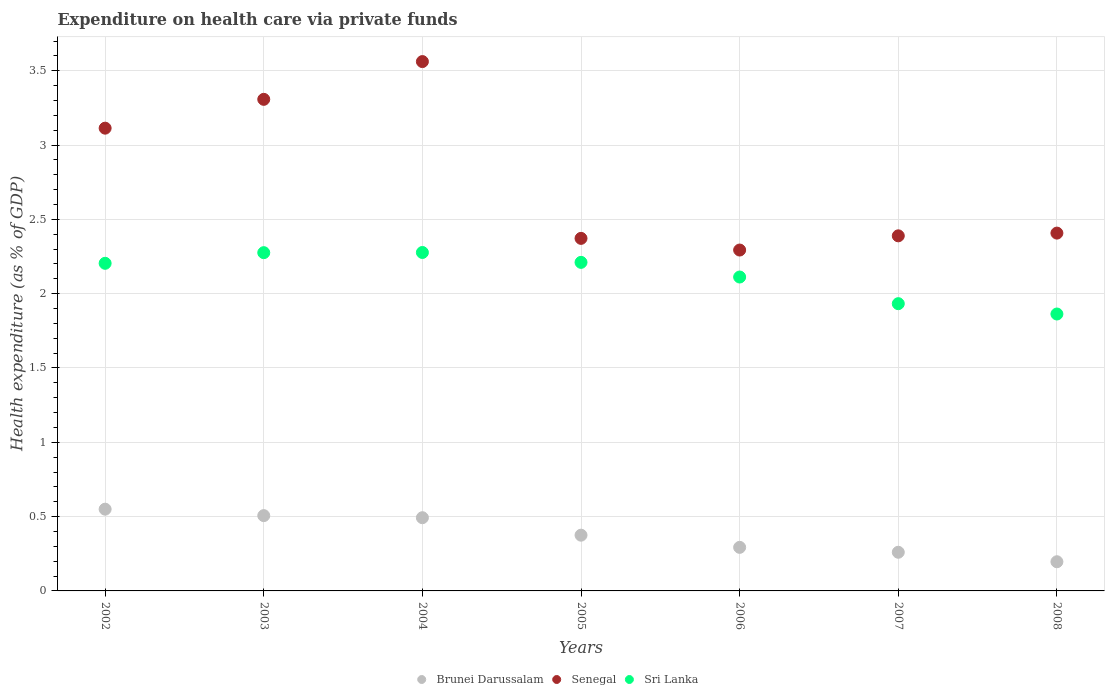Is the number of dotlines equal to the number of legend labels?
Your answer should be compact. Yes. What is the expenditure made on health care in Senegal in 2002?
Provide a succinct answer. 3.11. Across all years, what is the maximum expenditure made on health care in Senegal?
Your response must be concise. 3.56. Across all years, what is the minimum expenditure made on health care in Brunei Darussalam?
Your response must be concise. 0.2. In which year was the expenditure made on health care in Brunei Darussalam maximum?
Provide a short and direct response. 2002. What is the total expenditure made on health care in Brunei Darussalam in the graph?
Offer a terse response. 2.67. What is the difference between the expenditure made on health care in Sri Lanka in 2002 and that in 2006?
Ensure brevity in your answer.  0.09. What is the difference between the expenditure made on health care in Sri Lanka in 2002 and the expenditure made on health care in Brunei Darussalam in 2007?
Your answer should be compact. 1.94. What is the average expenditure made on health care in Brunei Darussalam per year?
Ensure brevity in your answer.  0.38. In the year 2002, what is the difference between the expenditure made on health care in Senegal and expenditure made on health care in Brunei Darussalam?
Provide a short and direct response. 2.56. In how many years, is the expenditure made on health care in Senegal greater than 0.9 %?
Ensure brevity in your answer.  7. What is the ratio of the expenditure made on health care in Brunei Darussalam in 2005 to that in 2006?
Offer a terse response. 1.28. Is the expenditure made on health care in Brunei Darussalam in 2004 less than that in 2007?
Keep it short and to the point. No. Is the difference between the expenditure made on health care in Senegal in 2003 and 2008 greater than the difference between the expenditure made on health care in Brunei Darussalam in 2003 and 2008?
Make the answer very short. Yes. What is the difference between the highest and the second highest expenditure made on health care in Senegal?
Your response must be concise. 0.25. What is the difference between the highest and the lowest expenditure made on health care in Brunei Darussalam?
Provide a short and direct response. 0.35. In how many years, is the expenditure made on health care in Senegal greater than the average expenditure made on health care in Senegal taken over all years?
Offer a very short reply. 3. Is it the case that in every year, the sum of the expenditure made on health care in Sri Lanka and expenditure made on health care in Senegal  is greater than the expenditure made on health care in Brunei Darussalam?
Ensure brevity in your answer.  Yes. Does the expenditure made on health care in Senegal monotonically increase over the years?
Ensure brevity in your answer.  No. Is the expenditure made on health care in Sri Lanka strictly less than the expenditure made on health care in Senegal over the years?
Your response must be concise. Yes. How many years are there in the graph?
Ensure brevity in your answer.  7. Does the graph contain any zero values?
Provide a succinct answer. No. Does the graph contain grids?
Make the answer very short. Yes. How many legend labels are there?
Provide a succinct answer. 3. What is the title of the graph?
Make the answer very short. Expenditure on health care via private funds. What is the label or title of the Y-axis?
Your answer should be very brief. Health expenditure (as % of GDP). What is the Health expenditure (as % of GDP) of Brunei Darussalam in 2002?
Your answer should be very brief. 0.55. What is the Health expenditure (as % of GDP) of Senegal in 2002?
Provide a short and direct response. 3.11. What is the Health expenditure (as % of GDP) in Sri Lanka in 2002?
Offer a very short reply. 2.2. What is the Health expenditure (as % of GDP) in Brunei Darussalam in 2003?
Ensure brevity in your answer.  0.51. What is the Health expenditure (as % of GDP) of Senegal in 2003?
Provide a short and direct response. 3.31. What is the Health expenditure (as % of GDP) of Sri Lanka in 2003?
Make the answer very short. 2.28. What is the Health expenditure (as % of GDP) in Brunei Darussalam in 2004?
Provide a succinct answer. 0.49. What is the Health expenditure (as % of GDP) in Senegal in 2004?
Offer a terse response. 3.56. What is the Health expenditure (as % of GDP) in Sri Lanka in 2004?
Provide a succinct answer. 2.28. What is the Health expenditure (as % of GDP) in Brunei Darussalam in 2005?
Keep it short and to the point. 0.38. What is the Health expenditure (as % of GDP) in Senegal in 2005?
Your response must be concise. 2.37. What is the Health expenditure (as % of GDP) of Sri Lanka in 2005?
Offer a terse response. 2.21. What is the Health expenditure (as % of GDP) of Brunei Darussalam in 2006?
Your answer should be compact. 0.29. What is the Health expenditure (as % of GDP) of Senegal in 2006?
Offer a very short reply. 2.29. What is the Health expenditure (as % of GDP) in Sri Lanka in 2006?
Give a very brief answer. 2.11. What is the Health expenditure (as % of GDP) in Brunei Darussalam in 2007?
Make the answer very short. 0.26. What is the Health expenditure (as % of GDP) in Senegal in 2007?
Your answer should be very brief. 2.39. What is the Health expenditure (as % of GDP) in Sri Lanka in 2007?
Your answer should be compact. 1.93. What is the Health expenditure (as % of GDP) in Brunei Darussalam in 2008?
Ensure brevity in your answer.  0.2. What is the Health expenditure (as % of GDP) in Senegal in 2008?
Offer a very short reply. 2.41. What is the Health expenditure (as % of GDP) in Sri Lanka in 2008?
Provide a succinct answer. 1.86. Across all years, what is the maximum Health expenditure (as % of GDP) in Brunei Darussalam?
Your answer should be very brief. 0.55. Across all years, what is the maximum Health expenditure (as % of GDP) in Senegal?
Offer a very short reply. 3.56. Across all years, what is the maximum Health expenditure (as % of GDP) of Sri Lanka?
Make the answer very short. 2.28. Across all years, what is the minimum Health expenditure (as % of GDP) of Brunei Darussalam?
Keep it short and to the point. 0.2. Across all years, what is the minimum Health expenditure (as % of GDP) in Senegal?
Provide a succinct answer. 2.29. Across all years, what is the minimum Health expenditure (as % of GDP) of Sri Lanka?
Your answer should be compact. 1.86. What is the total Health expenditure (as % of GDP) in Brunei Darussalam in the graph?
Offer a terse response. 2.67. What is the total Health expenditure (as % of GDP) in Senegal in the graph?
Make the answer very short. 19.45. What is the total Health expenditure (as % of GDP) of Sri Lanka in the graph?
Offer a very short reply. 14.88. What is the difference between the Health expenditure (as % of GDP) in Brunei Darussalam in 2002 and that in 2003?
Your answer should be very brief. 0.04. What is the difference between the Health expenditure (as % of GDP) of Senegal in 2002 and that in 2003?
Make the answer very short. -0.19. What is the difference between the Health expenditure (as % of GDP) of Sri Lanka in 2002 and that in 2003?
Your response must be concise. -0.07. What is the difference between the Health expenditure (as % of GDP) in Brunei Darussalam in 2002 and that in 2004?
Make the answer very short. 0.06. What is the difference between the Health expenditure (as % of GDP) in Senegal in 2002 and that in 2004?
Provide a succinct answer. -0.45. What is the difference between the Health expenditure (as % of GDP) in Sri Lanka in 2002 and that in 2004?
Ensure brevity in your answer.  -0.07. What is the difference between the Health expenditure (as % of GDP) in Brunei Darussalam in 2002 and that in 2005?
Give a very brief answer. 0.17. What is the difference between the Health expenditure (as % of GDP) in Senegal in 2002 and that in 2005?
Your answer should be compact. 0.74. What is the difference between the Health expenditure (as % of GDP) in Sri Lanka in 2002 and that in 2005?
Provide a short and direct response. -0.01. What is the difference between the Health expenditure (as % of GDP) of Brunei Darussalam in 2002 and that in 2006?
Provide a short and direct response. 0.26. What is the difference between the Health expenditure (as % of GDP) of Senegal in 2002 and that in 2006?
Provide a succinct answer. 0.82. What is the difference between the Health expenditure (as % of GDP) in Sri Lanka in 2002 and that in 2006?
Your answer should be compact. 0.09. What is the difference between the Health expenditure (as % of GDP) in Brunei Darussalam in 2002 and that in 2007?
Offer a terse response. 0.29. What is the difference between the Health expenditure (as % of GDP) of Senegal in 2002 and that in 2007?
Offer a terse response. 0.72. What is the difference between the Health expenditure (as % of GDP) in Sri Lanka in 2002 and that in 2007?
Provide a short and direct response. 0.27. What is the difference between the Health expenditure (as % of GDP) of Brunei Darussalam in 2002 and that in 2008?
Give a very brief answer. 0.35. What is the difference between the Health expenditure (as % of GDP) of Senegal in 2002 and that in 2008?
Give a very brief answer. 0.71. What is the difference between the Health expenditure (as % of GDP) in Sri Lanka in 2002 and that in 2008?
Provide a short and direct response. 0.34. What is the difference between the Health expenditure (as % of GDP) of Brunei Darussalam in 2003 and that in 2004?
Offer a terse response. 0.01. What is the difference between the Health expenditure (as % of GDP) in Senegal in 2003 and that in 2004?
Keep it short and to the point. -0.25. What is the difference between the Health expenditure (as % of GDP) in Sri Lanka in 2003 and that in 2004?
Provide a succinct answer. -0. What is the difference between the Health expenditure (as % of GDP) in Brunei Darussalam in 2003 and that in 2005?
Offer a very short reply. 0.13. What is the difference between the Health expenditure (as % of GDP) of Senegal in 2003 and that in 2005?
Offer a very short reply. 0.94. What is the difference between the Health expenditure (as % of GDP) in Sri Lanka in 2003 and that in 2005?
Offer a very short reply. 0.07. What is the difference between the Health expenditure (as % of GDP) in Brunei Darussalam in 2003 and that in 2006?
Provide a short and direct response. 0.21. What is the difference between the Health expenditure (as % of GDP) of Sri Lanka in 2003 and that in 2006?
Keep it short and to the point. 0.16. What is the difference between the Health expenditure (as % of GDP) of Brunei Darussalam in 2003 and that in 2007?
Your answer should be compact. 0.25. What is the difference between the Health expenditure (as % of GDP) of Senegal in 2003 and that in 2007?
Offer a terse response. 0.92. What is the difference between the Health expenditure (as % of GDP) of Sri Lanka in 2003 and that in 2007?
Your answer should be very brief. 0.34. What is the difference between the Health expenditure (as % of GDP) in Brunei Darussalam in 2003 and that in 2008?
Ensure brevity in your answer.  0.31. What is the difference between the Health expenditure (as % of GDP) in Senegal in 2003 and that in 2008?
Your response must be concise. 0.9. What is the difference between the Health expenditure (as % of GDP) in Sri Lanka in 2003 and that in 2008?
Your response must be concise. 0.41. What is the difference between the Health expenditure (as % of GDP) of Brunei Darussalam in 2004 and that in 2005?
Your answer should be compact. 0.12. What is the difference between the Health expenditure (as % of GDP) of Senegal in 2004 and that in 2005?
Your response must be concise. 1.19. What is the difference between the Health expenditure (as % of GDP) in Sri Lanka in 2004 and that in 2005?
Give a very brief answer. 0.07. What is the difference between the Health expenditure (as % of GDP) in Brunei Darussalam in 2004 and that in 2006?
Offer a very short reply. 0.2. What is the difference between the Health expenditure (as % of GDP) of Senegal in 2004 and that in 2006?
Your answer should be very brief. 1.27. What is the difference between the Health expenditure (as % of GDP) in Sri Lanka in 2004 and that in 2006?
Keep it short and to the point. 0.17. What is the difference between the Health expenditure (as % of GDP) in Brunei Darussalam in 2004 and that in 2007?
Make the answer very short. 0.23. What is the difference between the Health expenditure (as % of GDP) in Senegal in 2004 and that in 2007?
Provide a short and direct response. 1.17. What is the difference between the Health expenditure (as % of GDP) in Sri Lanka in 2004 and that in 2007?
Your answer should be compact. 0.34. What is the difference between the Health expenditure (as % of GDP) of Brunei Darussalam in 2004 and that in 2008?
Ensure brevity in your answer.  0.3. What is the difference between the Health expenditure (as % of GDP) in Senegal in 2004 and that in 2008?
Provide a short and direct response. 1.15. What is the difference between the Health expenditure (as % of GDP) of Sri Lanka in 2004 and that in 2008?
Offer a very short reply. 0.41. What is the difference between the Health expenditure (as % of GDP) in Brunei Darussalam in 2005 and that in 2006?
Provide a succinct answer. 0.08. What is the difference between the Health expenditure (as % of GDP) in Senegal in 2005 and that in 2006?
Your answer should be compact. 0.08. What is the difference between the Health expenditure (as % of GDP) in Sri Lanka in 2005 and that in 2006?
Give a very brief answer. 0.1. What is the difference between the Health expenditure (as % of GDP) of Brunei Darussalam in 2005 and that in 2007?
Ensure brevity in your answer.  0.12. What is the difference between the Health expenditure (as % of GDP) in Senegal in 2005 and that in 2007?
Provide a succinct answer. -0.02. What is the difference between the Health expenditure (as % of GDP) in Sri Lanka in 2005 and that in 2007?
Offer a very short reply. 0.28. What is the difference between the Health expenditure (as % of GDP) in Brunei Darussalam in 2005 and that in 2008?
Give a very brief answer. 0.18. What is the difference between the Health expenditure (as % of GDP) of Senegal in 2005 and that in 2008?
Give a very brief answer. -0.04. What is the difference between the Health expenditure (as % of GDP) of Sri Lanka in 2005 and that in 2008?
Your answer should be very brief. 0.35. What is the difference between the Health expenditure (as % of GDP) in Brunei Darussalam in 2006 and that in 2007?
Keep it short and to the point. 0.03. What is the difference between the Health expenditure (as % of GDP) in Senegal in 2006 and that in 2007?
Offer a terse response. -0.1. What is the difference between the Health expenditure (as % of GDP) in Sri Lanka in 2006 and that in 2007?
Your response must be concise. 0.18. What is the difference between the Health expenditure (as % of GDP) in Brunei Darussalam in 2006 and that in 2008?
Provide a succinct answer. 0.1. What is the difference between the Health expenditure (as % of GDP) in Senegal in 2006 and that in 2008?
Provide a short and direct response. -0.11. What is the difference between the Health expenditure (as % of GDP) in Sri Lanka in 2006 and that in 2008?
Keep it short and to the point. 0.25. What is the difference between the Health expenditure (as % of GDP) of Brunei Darussalam in 2007 and that in 2008?
Keep it short and to the point. 0.06. What is the difference between the Health expenditure (as % of GDP) in Senegal in 2007 and that in 2008?
Keep it short and to the point. -0.02. What is the difference between the Health expenditure (as % of GDP) of Sri Lanka in 2007 and that in 2008?
Provide a short and direct response. 0.07. What is the difference between the Health expenditure (as % of GDP) in Brunei Darussalam in 2002 and the Health expenditure (as % of GDP) in Senegal in 2003?
Offer a very short reply. -2.76. What is the difference between the Health expenditure (as % of GDP) in Brunei Darussalam in 2002 and the Health expenditure (as % of GDP) in Sri Lanka in 2003?
Ensure brevity in your answer.  -1.73. What is the difference between the Health expenditure (as % of GDP) of Senegal in 2002 and the Health expenditure (as % of GDP) of Sri Lanka in 2003?
Make the answer very short. 0.84. What is the difference between the Health expenditure (as % of GDP) in Brunei Darussalam in 2002 and the Health expenditure (as % of GDP) in Senegal in 2004?
Keep it short and to the point. -3.01. What is the difference between the Health expenditure (as % of GDP) of Brunei Darussalam in 2002 and the Health expenditure (as % of GDP) of Sri Lanka in 2004?
Provide a succinct answer. -1.73. What is the difference between the Health expenditure (as % of GDP) of Senegal in 2002 and the Health expenditure (as % of GDP) of Sri Lanka in 2004?
Your answer should be very brief. 0.84. What is the difference between the Health expenditure (as % of GDP) in Brunei Darussalam in 2002 and the Health expenditure (as % of GDP) in Senegal in 2005?
Your response must be concise. -1.82. What is the difference between the Health expenditure (as % of GDP) of Brunei Darussalam in 2002 and the Health expenditure (as % of GDP) of Sri Lanka in 2005?
Your answer should be compact. -1.66. What is the difference between the Health expenditure (as % of GDP) in Senegal in 2002 and the Health expenditure (as % of GDP) in Sri Lanka in 2005?
Make the answer very short. 0.9. What is the difference between the Health expenditure (as % of GDP) of Brunei Darussalam in 2002 and the Health expenditure (as % of GDP) of Senegal in 2006?
Your answer should be compact. -1.74. What is the difference between the Health expenditure (as % of GDP) of Brunei Darussalam in 2002 and the Health expenditure (as % of GDP) of Sri Lanka in 2006?
Give a very brief answer. -1.56. What is the difference between the Health expenditure (as % of GDP) in Brunei Darussalam in 2002 and the Health expenditure (as % of GDP) in Senegal in 2007?
Give a very brief answer. -1.84. What is the difference between the Health expenditure (as % of GDP) in Brunei Darussalam in 2002 and the Health expenditure (as % of GDP) in Sri Lanka in 2007?
Provide a short and direct response. -1.38. What is the difference between the Health expenditure (as % of GDP) of Senegal in 2002 and the Health expenditure (as % of GDP) of Sri Lanka in 2007?
Make the answer very short. 1.18. What is the difference between the Health expenditure (as % of GDP) in Brunei Darussalam in 2002 and the Health expenditure (as % of GDP) in Senegal in 2008?
Offer a terse response. -1.86. What is the difference between the Health expenditure (as % of GDP) of Brunei Darussalam in 2002 and the Health expenditure (as % of GDP) of Sri Lanka in 2008?
Your answer should be compact. -1.31. What is the difference between the Health expenditure (as % of GDP) in Senegal in 2002 and the Health expenditure (as % of GDP) in Sri Lanka in 2008?
Offer a very short reply. 1.25. What is the difference between the Health expenditure (as % of GDP) in Brunei Darussalam in 2003 and the Health expenditure (as % of GDP) in Senegal in 2004?
Your answer should be very brief. -3.06. What is the difference between the Health expenditure (as % of GDP) in Brunei Darussalam in 2003 and the Health expenditure (as % of GDP) in Sri Lanka in 2004?
Offer a very short reply. -1.77. What is the difference between the Health expenditure (as % of GDP) of Senegal in 2003 and the Health expenditure (as % of GDP) of Sri Lanka in 2004?
Give a very brief answer. 1.03. What is the difference between the Health expenditure (as % of GDP) of Brunei Darussalam in 2003 and the Health expenditure (as % of GDP) of Senegal in 2005?
Offer a very short reply. -1.87. What is the difference between the Health expenditure (as % of GDP) in Brunei Darussalam in 2003 and the Health expenditure (as % of GDP) in Sri Lanka in 2005?
Offer a terse response. -1.7. What is the difference between the Health expenditure (as % of GDP) in Senegal in 2003 and the Health expenditure (as % of GDP) in Sri Lanka in 2005?
Keep it short and to the point. 1.1. What is the difference between the Health expenditure (as % of GDP) in Brunei Darussalam in 2003 and the Health expenditure (as % of GDP) in Senegal in 2006?
Make the answer very short. -1.79. What is the difference between the Health expenditure (as % of GDP) of Brunei Darussalam in 2003 and the Health expenditure (as % of GDP) of Sri Lanka in 2006?
Keep it short and to the point. -1.61. What is the difference between the Health expenditure (as % of GDP) of Senegal in 2003 and the Health expenditure (as % of GDP) of Sri Lanka in 2006?
Offer a terse response. 1.2. What is the difference between the Health expenditure (as % of GDP) of Brunei Darussalam in 2003 and the Health expenditure (as % of GDP) of Senegal in 2007?
Ensure brevity in your answer.  -1.88. What is the difference between the Health expenditure (as % of GDP) of Brunei Darussalam in 2003 and the Health expenditure (as % of GDP) of Sri Lanka in 2007?
Offer a terse response. -1.43. What is the difference between the Health expenditure (as % of GDP) in Senegal in 2003 and the Health expenditure (as % of GDP) in Sri Lanka in 2007?
Ensure brevity in your answer.  1.37. What is the difference between the Health expenditure (as % of GDP) in Brunei Darussalam in 2003 and the Health expenditure (as % of GDP) in Senegal in 2008?
Provide a succinct answer. -1.9. What is the difference between the Health expenditure (as % of GDP) of Brunei Darussalam in 2003 and the Health expenditure (as % of GDP) of Sri Lanka in 2008?
Provide a short and direct response. -1.36. What is the difference between the Health expenditure (as % of GDP) of Senegal in 2003 and the Health expenditure (as % of GDP) of Sri Lanka in 2008?
Your answer should be compact. 1.44. What is the difference between the Health expenditure (as % of GDP) in Brunei Darussalam in 2004 and the Health expenditure (as % of GDP) in Senegal in 2005?
Provide a short and direct response. -1.88. What is the difference between the Health expenditure (as % of GDP) in Brunei Darussalam in 2004 and the Health expenditure (as % of GDP) in Sri Lanka in 2005?
Keep it short and to the point. -1.72. What is the difference between the Health expenditure (as % of GDP) of Senegal in 2004 and the Health expenditure (as % of GDP) of Sri Lanka in 2005?
Give a very brief answer. 1.35. What is the difference between the Health expenditure (as % of GDP) in Brunei Darussalam in 2004 and the Health expenditure (as % of GDP) in Senegal in 2006?
Give a very brief answer. -1.8. What is the difference between the Health expenditure (as % of GDP) in Brunei Darussalam in 2004 and the Health expenditure (as % of GDP) in Sri Lanka in 2006?
Provide a succinct answer. -1.62. What is the difference between the Health expenditure (as % of GDP) in Senegal in 2004 and the Health expenditure (as % of GDP) in Sri Lanka in 2006?
Give a very brief answer. 1.45. What is the difference between the Health expenditure (as % of GDP) in Brunei Darussalam in 2004 and the Health expenditure (as % of GDP) in Senegal in 2007?
Provide a succinct answer. -1.9. What is the difference between the Health expenditure (as % of GDP) in Brunei Darussalam in 2004 and the Health expenditure (as % of GDP) in Sri Lanka in 2007?
Your response must be concise. -1.44. What is the difference between the Health expenditure (as % of GDP) in Senegal in 2004 and the Health expenditure (as % of GDP) in Sri Lanka in 2007?
Provide a succinct answer. 1.63. What is the difference between the Health expenditure (as % of GDP) in Brunei Darussalam in 2004 and the Health expenditure (as % of GDP) in Senegal in 2008?
Ensure brevity in your answer.  -1.92. What is the difference between the Health expenditure (as % of GDP) in Brunei Darussalam in 2004 and the Health expenditure (as % of GDP) in Sri Lanka in 2008?
Offer a very short reply. -1.37. What is the difference between the Health expenditure (as % of GDP) of Senegal in 2004 and the Health expenditure (as % of GDP) of Sri Lanka in 2008?
Your response must be concise. 1.7. What is the difference between the Health expenditure (as % of GDP) in Brunei Darussalam in 2005 and the Health expenditure (as % of GDP) in Senegal in 2006?
Make the answer very short. -1.92. What is the difference between the Health expenditure (as % of GDP) in Brunei Darussalam in 2005 and the Health expenditure (as % of GDP) in Sri Lanka in 2006?
Ensure brevity in your answer.  -1.74. What is the difference between the Health expenditure (as % of GDP) in Senegal in 2005 and the Health expenditure (as % of GDP) in Sri Lanka in 2006?
Ensure brevity in your answer.  0.26. What is the difference between the Health expenditure (as % of GDP) in Brunei Darussalam in 2005 and the Health expenditure (as % of GDP) in Senegal in 2007?
Offer a terse response. -2.01. What is the difference between the Health expenditure (as % of GDP) in Brunei Darussalam in 2005 and the Health expenditure (as % of GDP) in Sri Lanka in 2007?
Offer a very short reply. -1.56. What is the difference between the Health expenditure (as % of GDP) of Senegal in 2005 and the Health expenditure (as % of GDP) of Sri Lanka in 2007?
Offer a terse response. 0.44. What is the difference between the Health expenditure (as % of GDP) of Brunei Darussalam in 2005 and the Health expenditure (as % of GDP) of Senegal in 2008?
Keep it short and to the point. -2.03. What is the difference between the Health expenditure (as % of GDP) of Brunei Darussalam in 2005 and the Health expenditure (as % of GDP) of Sri Lanka in 2008?
Your answer should be compact. -1.49. What is the difference between the Health expenditure (as % of GDP) of Senegal in 2005 and the Health expenditure (as % of GDP) of Sri Lanka in 2008?
Offer a terse response. 0.51. What is the difference between the Health expenditure (as % of GDP) in Brunei Darussalam in 2006 and the Health expenditure (as % of GDP) in Senegal in 2007?
Your answer should be compact. -2.1. What is the difference between the Health expenditure (as % of GDP) in Brunei Darussalam in 2006 and the Health expenditure (as % of GDP) in Sri Lanka in 2007?
Provide a succinct answer. -1.64. What is the difference between the Health expenditure (as % of GDP) of Senegal in 2006 and the Health expenditure (as % of GDP) of Sri Lanka in 2007?
Your answer should be compact. 0.36. What is the difference between the Health expenditure (as % of GDP) of Brunei Darussalam in 2006 and the Health expenditure (as % of GDP) of Senegal in 2008?
Offer a very short reply. -2.11. What is the difference between the Health expenditure (as % of GDP) of Brunei Darussalam in 2006 and the Health expenditure (as % of GDP) of Sri Lanka in 2008?
Provide a short and direct response. -1.57. What is the difference between the Health expenditure (as % of GDP) of Senegal in 2006 and the Health expenditure (as % of GDP) of Sri Lanka in 2008?
Your answer should be very brief. 0.43. What is the difference between the Health expenditure (as % of GDP) of Brunei Darussalam in 2007 and the Health expenditure (as % of GDP) of Senegal in 2008?
Make the answer very short. -2.15. What is the difference between the Health expenditure (as % of GDP) in Brunei Darussalam in 2007 and the Health expenditure (as % of GDP) in Sri Lanka in 2008?
Provide a succinct answer. -1.6. What is the difference between the Health expenditure (as % of GDP) in Senegal in 2007 and the Health expenditure (as % of GDP) in Sri Lanka in 2008?
Your response must be concise. 0.53. What is the average Health expenditure (as % of GDP) of Brunei Darussalam per year?
Provide a short and direct response. 0.38. What is the average Health expenditure (as % of GDP) of Senegal per year?
Ensure brevity in your answer.  2.78. What is the average Health expenditure (as % of GDP) of Sri Lanka per year?
Make the answer very short. 2.13. In the year 2002, what is the difference between the Health expenditure (as % of GDP) in Brunei Darussalam and Health expenditure (as % of GDP) in Senegal?
Provide a succinct answer. -2.56. In the year 2002, what is the difference between the Health expenditure (as % of GDP) in Brunei Darussalam and Health expenditure (as % of GDP) in Sri Lanka?
Your answer should be very brief. -1.65. In the year 2002, what is the difference between the Health expenditure (as % of GDP) of Senegal and Health expenditure (as % of GDP) of Sri Lanka?
Offer a terse response. 0.91. In the year 2003, what is the difference between the Health expenditure (as % of GDP) of Brunei Darussalam and Health expenditure (as % of GDP) of Senegal?
Offer a very short reply. -2.8. In the year 2003, what is the difference between the Health expenditure (as % of GDP) in Brunei Darussalam and Health expenditure (as % of GDP) in Sri Lanka?
Your answer should be compact. -1.77. In the year 2003, what is the difference between the Health expenditure (as % of GDP) of Senegal and Health expenditure (as % of GDP) of Sri Lanka?
Your response must be concise. 1.03. In the year 2004, what is the difference between the Health expenditure (as % of GDP) of Brunei Darussalam and Health expenditure (as % of GDP) of Senegal?
Offer a terse response. -3.07. In the year 2004, what is the difference between the Health expenditure (as % of GDP) of Brunei Darussalam and Health expenditure (as % of GDP) of Sri Lanka?
Your answer should be compact. -1.78. In the year 2004, what is the difference between the Health expenditure (as % of GDP) in Senegal and Health expenditure (as % of GDP) in Sri Lanka?
Your response must be concise. 1.28. In the year 2005, what is the difference between the Health expenditure (as % of GDP) of Brunei Darussalam and Health expenditure (as % of GDP) of Senegal?
Make the answer very short. -2. In the year 2005, what is the difference between the Health expenditure (as % of GDP) of Brunei Darussalam and Health expenditure (as % of GDP) of Sri Lanka?
Your response must be concise. -1.84. In the year 2005, what is the difference between the Health expenditure (as % of GDP) of Senegal and Health expenditure (as % of GDP) of Sri Lanka?
Your answer should be compact. 0.16. In the year 2006, what is the difference between the Health expenditure (as % of GDP) in Brunei Darussalam and Health expenditure (as % of GDP) in Senegal?
Your response must be concise. -2. In the year 2006, what is the difference between the Health expenditure (as % of GDP) in Brunei Darussalam and Health expenditure (as % of GDP) in Sri Lanka?
Offer a very short reply. -1.82. In the year 2006, what is the difference between the Health expenditure (as % of GDP) of Senegal and Health expenditure (as % of GDP) of Sri Lanka?
Provide a succinct answer. 0.18. In the year 2007, what is the difference between the Health expenditure (as % of GDP) of Brunei Darussalam and Health expenditure (as % of GDP) of Senegal?
Offer a very short reply. -2.13. In the year 2007, what is the difference between the Health expenditure (as % of GDP) of Brunei Darussalam and Health expenditure (as % of GDP) of Sri Lanka?
Ensure brevity in your answer.  -1.67. In the year 2007, what is the difference between the Health expenditure (as % of GDP) of Senegal and Health expenditure (as % of GDP) of Sri Lanka?
Offer a very short reply. 0.46. In the year 2008, what is the difference between the Health expenditure (as % of GDP) in Brunei Darussalam and Health expenditure (as % of GDP) in Senegal?
Provide a succinct answer. -2.21. In the year 2008, what is the difference between the Health expenditure (as % of GDP) in Brunei Darussalam and Health expenditure (as % of GDP) in Sri Lanka?
Your answer should be very brief. -1.67. In the year 2008, what is the difference between the Health expenditure (as % of GDP) in Senegal and Health expenditure (as % of GDP) in Sri Lanka?
Ensure brevity in your answer.  0.54. What is the ratio of the Health expenditure (as % of GDP) in Brunei Darussalam in 2002 to that in 2003?
Offer a terse response. 1.09. What is the ratio of the Health expenditure (as % of GDP) of Senegal in 2002 to that in 2003?
Your answer should be very brief. 0.94. What is the ratio of the Health expenditure (as % of GDP) in Sri Lanka in 2002 to that in 2003?
Give a very brief answer. 0.97. What is the ratio of the Health expenditure (as % of GDP) in Brunei Darussalam in 2002 to that in 2004?
Give a very brief answer. 1.12. What is the ratio of the Health expenditure (as % of GDP) in Senegal in 2002 to that in 2004?
Your response must be concise. 0.87. What is the ratio of the Health expenditure (as % of GDP) of Brunei Darussalam in 2002 to that in 2005?
Your response must be concise. 1.47. What is the ratio of the Health expenditure (as % of GDP) in Senegal in 2002 to that in 2005?
Make the answer very short. 1.31. What is the ratio of the Health expenditure (as % of GDP) in Brunei Darussalam in 2002 to that in 2006?
Offer a very short reply. 1.88. What is the ratio of the Health expenditure (as % of GDP) in Senegal in 2002 to that in 2006?
Offer a very short reply. 1.36. What is the ratio of the Health expenditure (as % of GDP) in Sri Lanka in 2002 to that in 2006?
Offer a very short reply. 1.04. What is the ratio of the Health expenditure (as % of GDP) of Brunei Darussalam in 2002 to that in 2007?
Your answer should be compact. 2.11. What is the ratio of the Health expenditure (as % of GDP) in Senegal in 2002 to that in 2007?
Offer a very short reply. 1.3. What is the ratio of the Health expenditure (as % of GDP) in Sri Lanka in 2002 to that in 2007?
Ensure brevity in your answer.  1.14. What is the ratio of the Health expenditure (as % of GDP) in Brunei Darussalam in 2002 to that in 2008?
Ensure brevity in your answer.  2.8. What is the ratio of the Health expenditure (as % of GDP) in Senegal in 2002 to that in 2008?
Offer a very short reply. 1.29. What is the ratio of the Health expenditure (as % of GDP) of Sri Lanka in 2002 to that in 2008?
Provide a succinct answer. 1.18. What is the ratio of the Health expenditure (as % of GDP) in Brunei Darussalam in 2003 to that in 2004?
Your response must be concise. 1.03. What is the ratio of the Health expenditure (as % of GDP) of Senegal in 2003 to that in 2004?
Offer a very short reply. 0.93. What is the ratio of the Health expenditure (as % of GDP) in Sri Lanka in 2003 to that in 2004?
Your response must be concise. 1. What is the ratio of the Health expenditure (as % of GDP) in Brunei Darussalam in 2003 to that in 2005?
Your answer should be compact. 1.35. What is the ratio of the Health expenditure (as % of GDP) in Senegal in 2003 to that in 2005?
Keep it short and to the point. 1.39. What is the ratio of the Health expenditure (as % of GDP) in Sri Lanka in 2003 to that in 2005?
Offer a very short reply. 1.03. What is the ratio of the Health expenditure (as % of GDP) of Brunei Darussalam in 2003 to that in 2006?
Offer a very short reply. 1.73. What is the ratio of the Health expenditure (as % of GDP) of Senegal in 2003 to that in 2006?
Your answer should be compact. 1.44. What is the ratio of the Health expenditure (as % of GDP) of Sri Lanka in 2003 to that in 2006?
Provide a short and direct response. 1.08. What is the ratio of the Health expenditure (as % of GDP) of Brunei Darussalam in 2003 to that in 2007?
Provide a succinct answer. 1.95. What is the ratio of the Health expenditure (as % of GDP) of Senegal in 2003 to that in 2007?
Keep it short and to the point. 1.38. What is the ratio of the Health expenditure (as % of GDP) of Sri Lanka in 2003 to that in 2007?
Your answer should be compact. 1.18. What is the ratio of the Health expenditure (as % of GDP) of Brunei Darussalam in 2003 to that in 2008?
Offer a very short reply. 2.58. What is the ratio of the Health expenditure (as % of GDP) in Senegal in 2003 to that in 2008?
Keep it short and to the point. 1.37. What is the ratio of the Health expenditure (as % of GDP) of Sri Lanka in 2003 to that in 2008?
Make the answer very short. 1.22. What is the ratio of the Health expenditure (as % of GDP) of Brunei Darussalam in 2004 to that in 2005?
Provide a short and direct response. 1.31. What is the ratio of the Health expenditure (as % of GDP) of Senegal in 2004 to that in 2005?
Your response must be concise. 1.5. What is the ratio of the Health expenditure (as % of GDP) of Sri Lanka in 2004 to that in 2005?
Offer a very short reply. 1.03. What is the ratio of the Health expenditure (as % of GDP) in Brunei Darussalam in 2004 to that in 2006?
Make the answer very short. 1.68. What is the ratio of the Health expenditure (as % of GDP) of Senegal in 2004 to that in 2006?
Offer a terse response. 1.55. What is the ratio of the Health expenditure (as % of GDP) in Sri Lanka in 2004 to that in 2006?
Keep it short and to the point. 1.08. What is the ratio of the Health expenditure (as % of GDP) in Brunei Darussalam in 2004 to that in 2007?
Offer a terse response. 1.89. What is the ratio of the Health expenditure (as % of GDP) in Senegal in 2004 to that in 2007?
Your answer should be very brief. 1.49. What is the ratio of the Health expenditure (as % of GDP) of Sri Lanka in 2004 to that in 2007?
Offer a very short reply. 1.18. What is the ratio of the Health expenditure (as % of GDP) in Brunei Darussalam in 2004 to that in 2008?
Your answer should be compact. 2.51. What is the ratio of the Health expenditure (as % of GDP) of Senegal in 2004 to that in 2008?
Make the answer very short. 1.48. What is the ratio of the Health expenditure (as % of GDP) in Sri Lanka in 2004 to that in 2008?
Your response must be concise. 1.22. What is the ratio of the Health expenditure (as % of GDP) in Brunei Darussalam in 2005 to that in 2006?
Make the answer very short. 1.28. What is the ratio of the Health expenditure (as % of GDP) of Senegal in 2005 to that in 2006?
Your answer should be very brief. 1.03. What is the ratio of the Health expenditure (as % of GDP) in Sri Lanka in 2005 to that in 2006?
Your answer should be compact. 1.05. What is the ratio of the Health expenditure (as % of GDP) in Brunei Darussalam in 2005 to that in 2007?
Your answer should be compact. 1.44. What is the ratio of the Health expenditure (as % of GDP) in Sri Lanka in 2005 to that in 2007?
Offer a very short reply. 1.14. What is the ratio of the Health expenditure (as % of GDP) in Brunei Darussalam in 2005 to that in 2008?
Offer a very short reply. 1.91. What is the ratio of the Health expenditure (as % of GDP) in Sri Lanka in 2005 to that in 2008?
Give a very brief answer. 1.19. What is the ratio of the Health expenditure (as % of GDP) of Brunei Darussalam in 2006 to that in 2007?
Provide a succinct answer. 1.13. What is the ratio of the Health expenditure (as % of GDP) in Senegal in 2006 to that in 2007?
Offer a terse response. 0.96. What is the ratio of the Health expenditure (as % of GDP) in Sri Lanka in 2006 to that in 2007?
Your answer should be compact. 1.09. What is the ratio of the Health expenditure (as % of GDP) in Brunei Darussalam in 2006 to that in 2008?
Your answer should be compact. 1.49. What is the ratio of the Health expenditure (as % of GDP) in Senegal in 2006 to that in 2008?
Provide a short and direct response. 0.95. What is the ratio of the Health expenditure (as % of GDP) in Sri Lanka in 2006 to that in 2008?
Offer a terse response. 1.13. What is the ratio of the Health expenditure (as % of GDP) of Brunei Darussalam in 2007 to that in 2008?
Offer a terse response. 1.32. What is the ratio of the Health expenditure (as % of GDP) in Senegal in 2007 to that in 2008?
Your answer should be very brief. 0.99. What is the ratio of the Health expenditure (as % of GDP) in Sri Lanka in 2007 to that in 2008?
Provide a short and direct response. 1.04. What is the difference between the highest and the second highest Health expenditure (as % of GDP) in Brunei Darussalam?
Your answer should be compact. 0.04. What is the difference between the highest and the second highest Health expenditure (as % of GDP) in Senegal?
Your response must be concise. 0.25. What is the difference between the highest and the second highest Health expenditure (as % of GDP) in Sri Lanka?
Your response must be concise. 0. What is the difference between the highest and the lowest Health expenditure (as % of GDP) of Brunei Darussalam?
Provide a short and direct response. 0.35. What is the difference between the highest and the lowest Health expenditure (as % of GDP) in Senegal?
Give a very brief answer. 1.27. What is the difference between the highest and the lowest Health expenditure (as % of GDP) of Sri Lanka?
Offer a terse response. 0.41. 